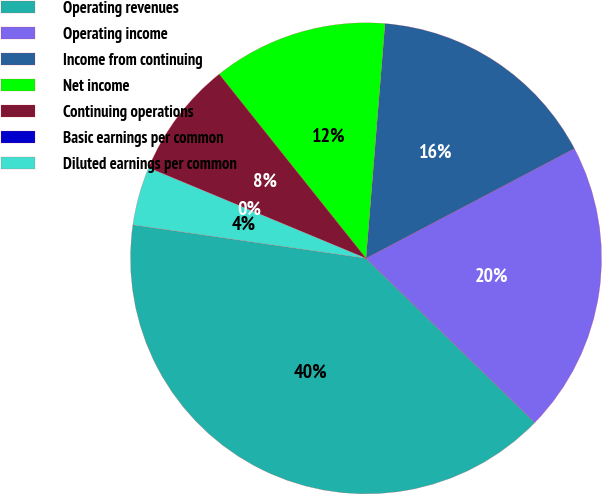<chart> <loc_0><loc_0><loc_500><loc_500><pie_chart><fcel>Operating revenues<fcel>Operating income<fcel>Income from continuing<fcel>Net income<fcel>Continuing operations<fcel>Basic earnings per common<fcel>Diluted earnings per common<nl><fcel>39.99%<fcel>20.0%<fcel>16.0%<fcel>12.0%<fcel>8.0%<fcel>0.01%<fcel>4.01%<nl></chart> 